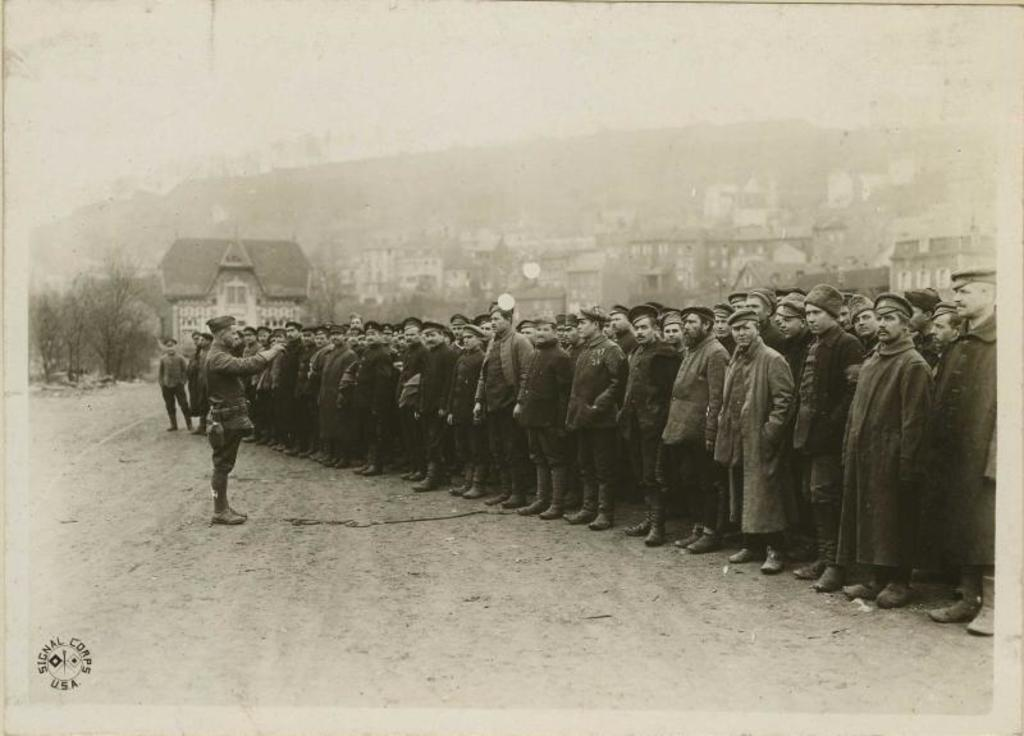What is happening in the center of the image? There is a group of persons standing in the center of the image. What can be seen in the background of the image? There are trees, buildings, and mountains in the background of the image. What type of glue is being used by the persons in the image? There is no glue present in the image, and therefore no such activity can be observed. How many umbrellas are visible in the image? There are no umbrellas visible in the image. 